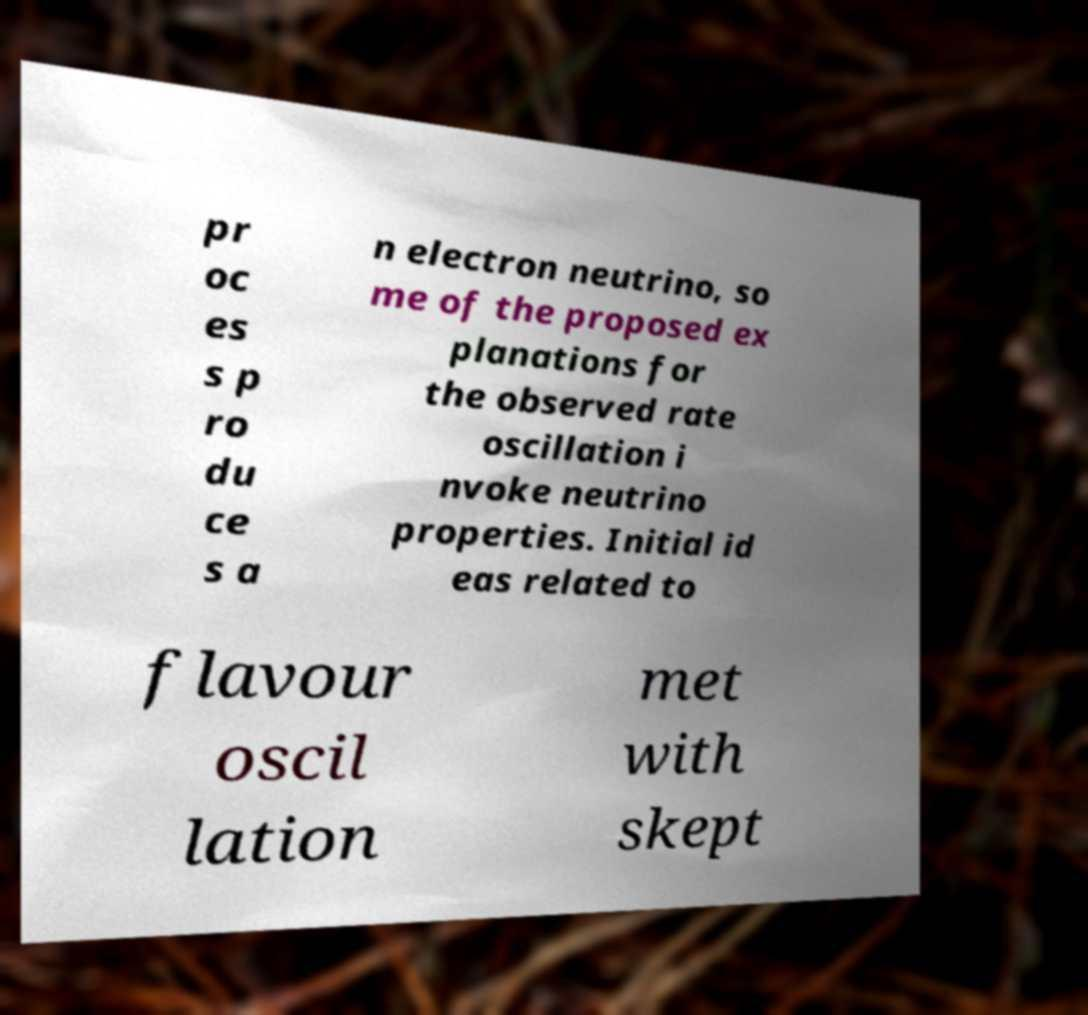Please read and relay the text visible in this image. What does it say? pr oc es s p ro du ce s a n electron neutrino, so me of the proposed ex planations for the observed rate oscillation i nvoke neutrino properties. Initial id eas related to flavour oscil lation met with skept 